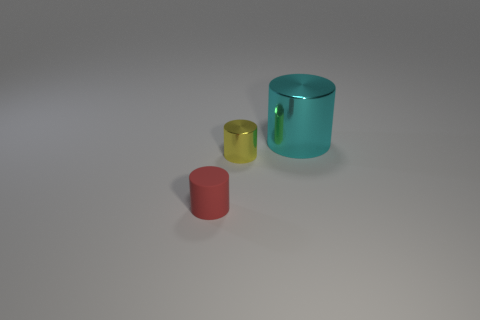Add 3 tiny gray rubber things. How many objects exist? 6 Add 2 cyan metal cylinders. How many cyan metal cylinders exist? 3 Subtract 0 purple spheres. How many objects are left? 3 Subtract all yellow shiny cylinders. Subtract all red matte cylinders. How many objects are left? 1 Add 2 yellow metal things. How many yellow metal things are left? 3 